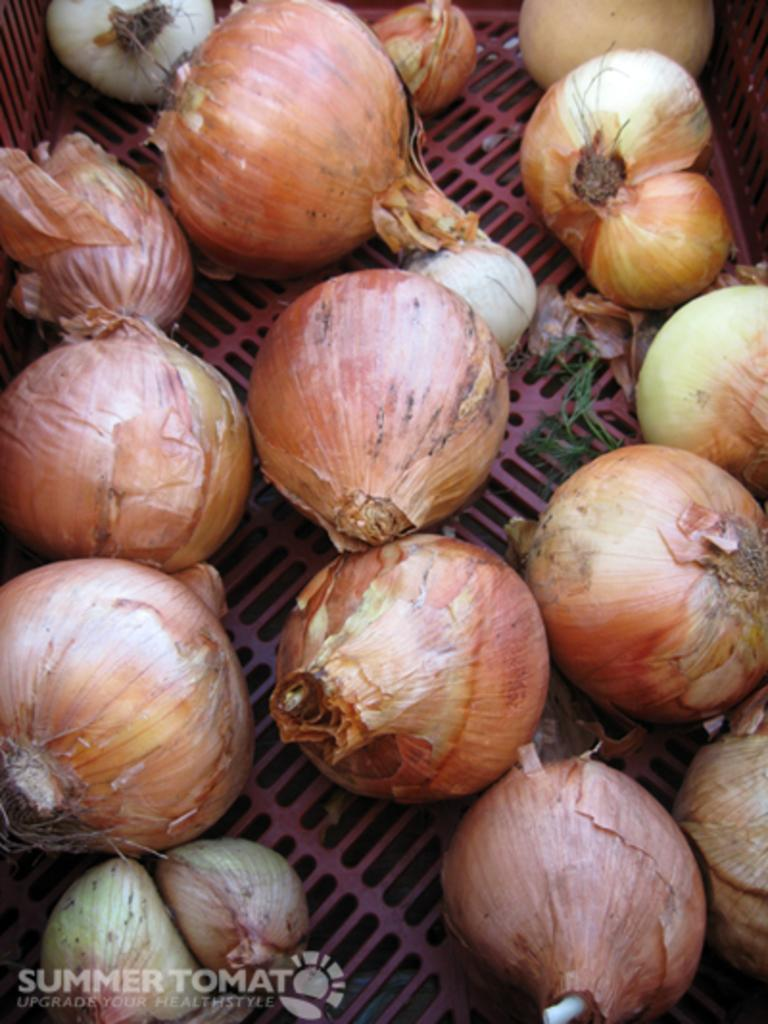What color is the grilled surface in the image? The grilled surface in the image is pink in color. What is on top of the grilled surface? There are onions on the grilled surface. How many mittens can be seen on the grilled surface in the image? There are no mittens present on the grilled surface in the image. 